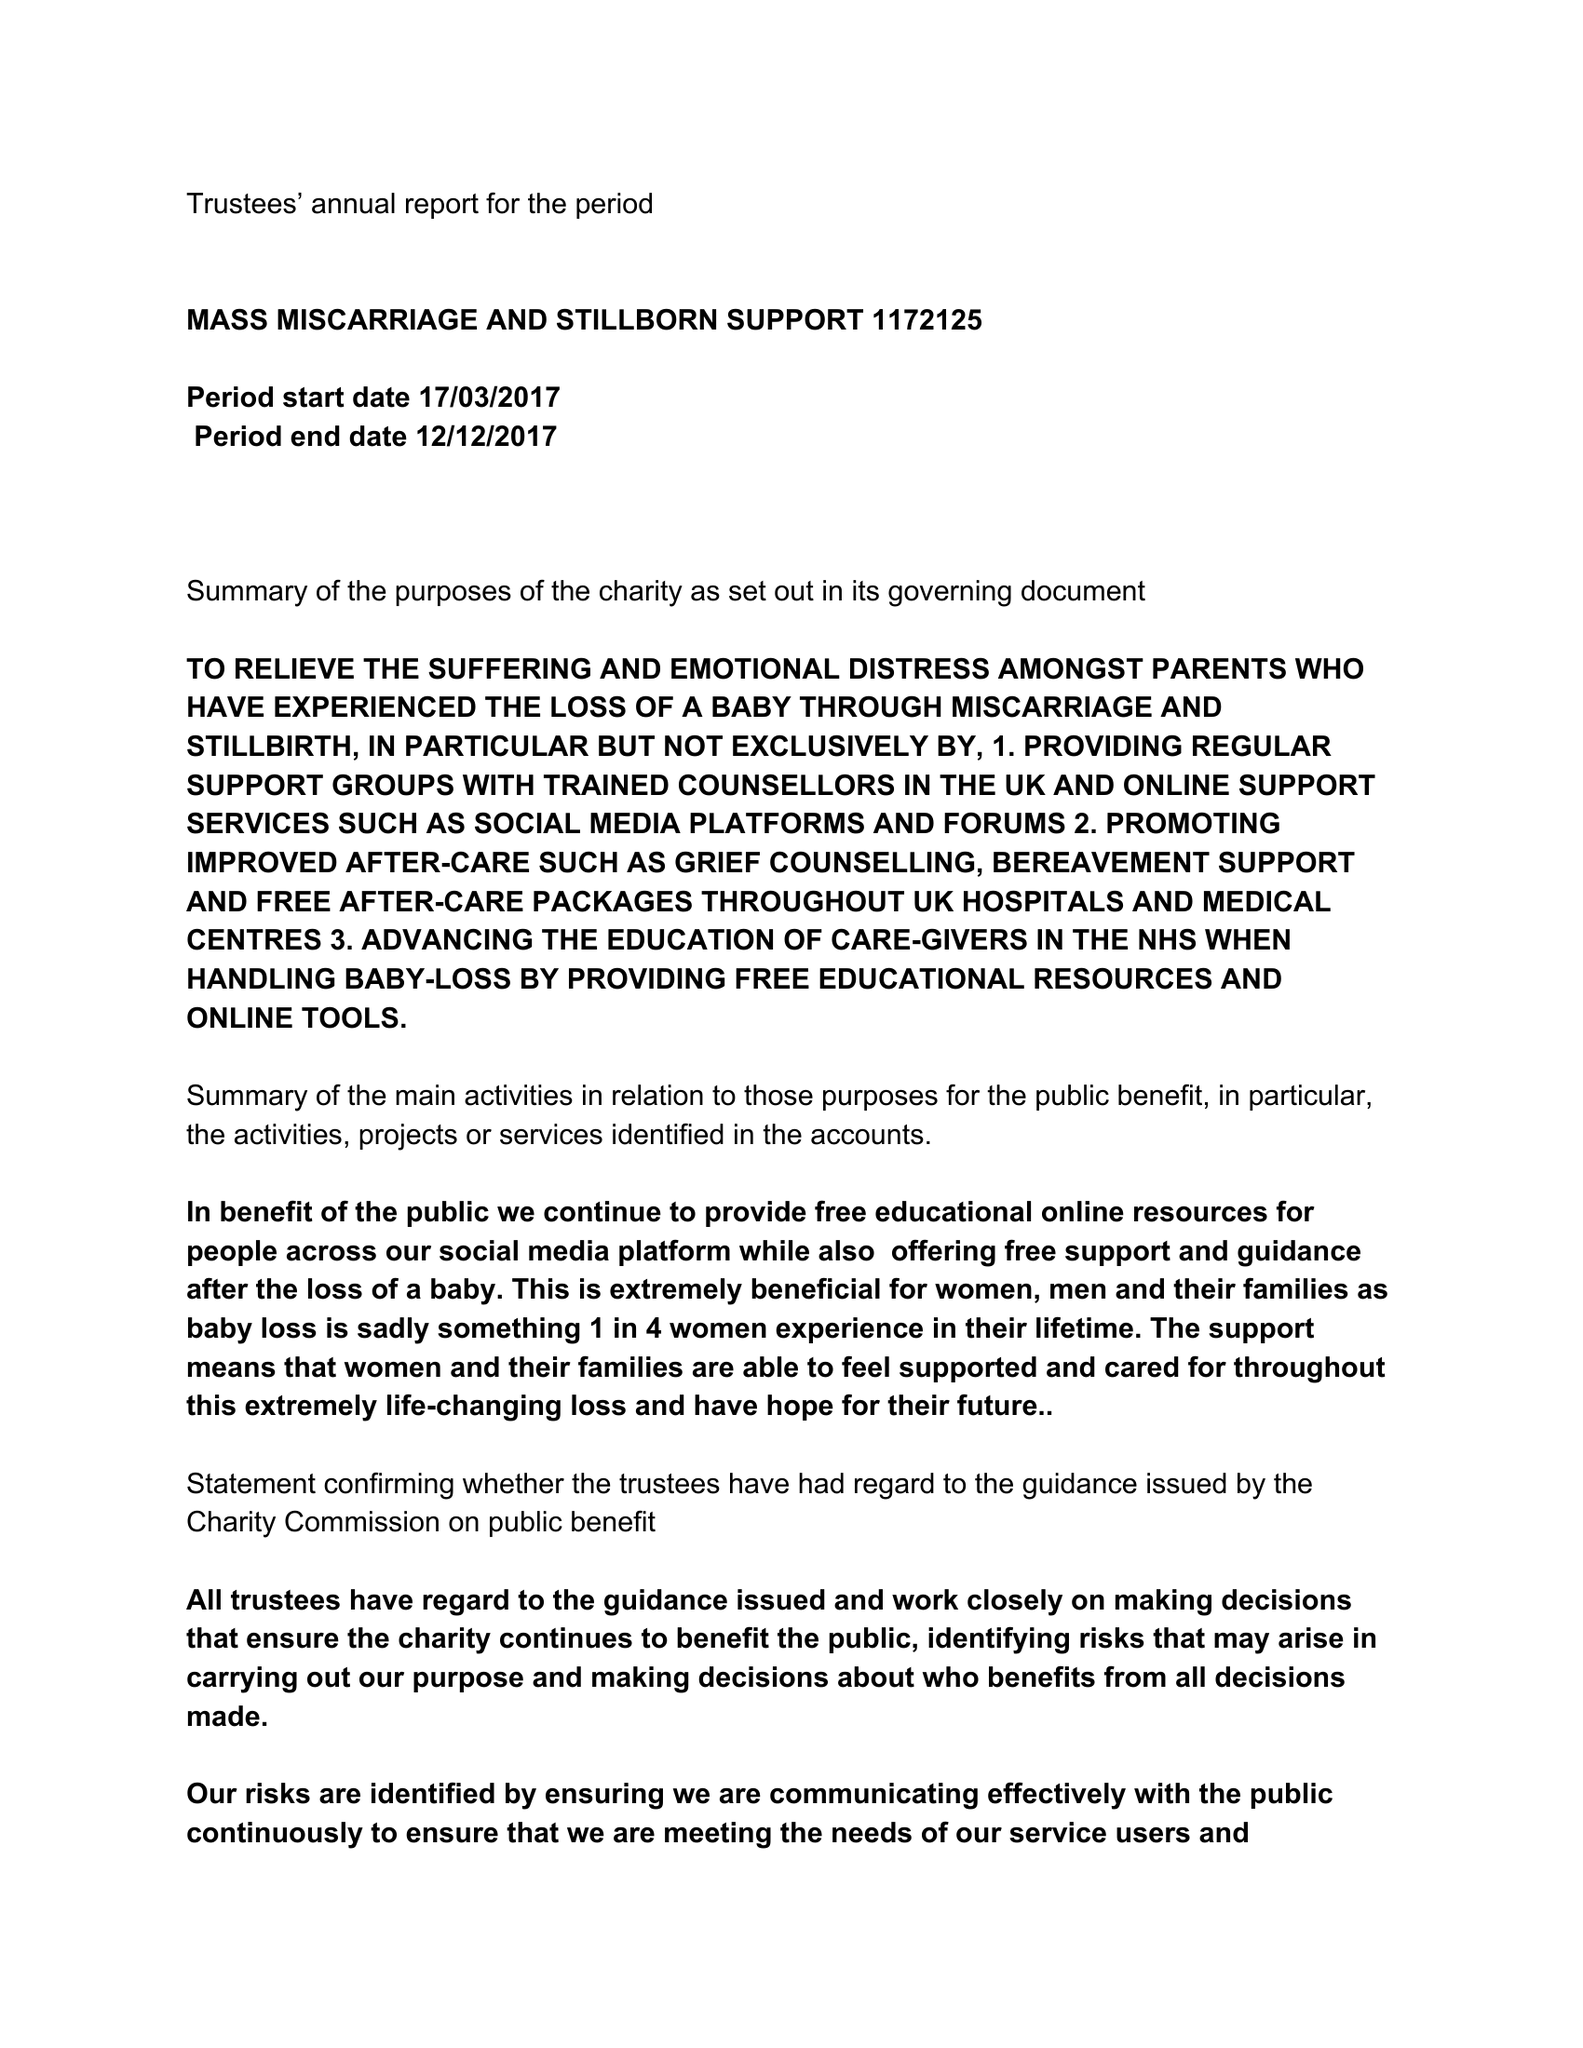What is the value for the income_annually_in_british_pounds?
Answer the question using a single word or phrase. None 